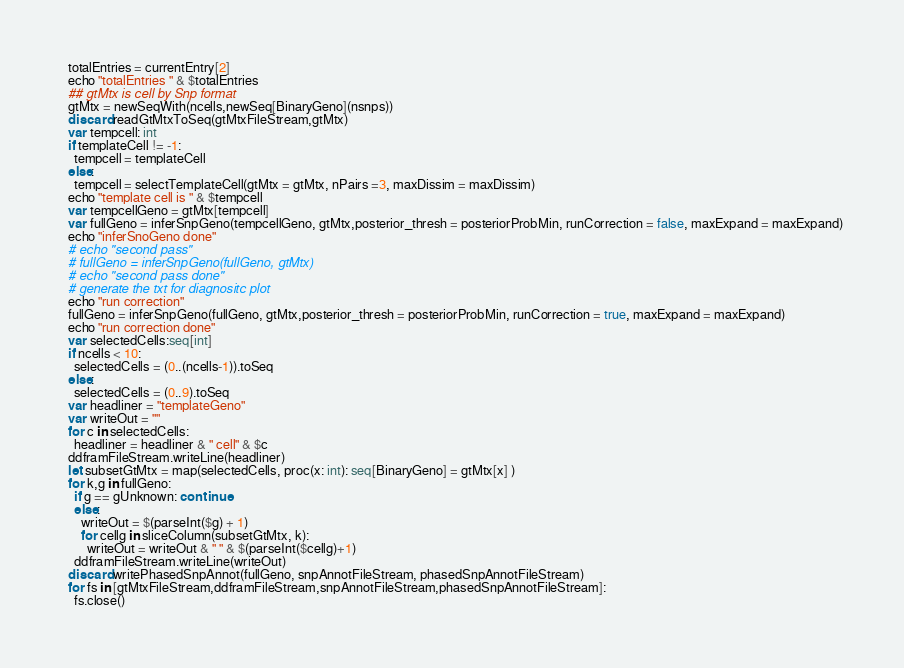Convert code to text. <code><loc_0><loc_0><loc_500><loc_500><_Nim_>  totalEntries = currentEntry[2]
  echo "totalEntries " & $totalEntries
  ## gtMtx is cell by Snp format
  gtMtx = newSeqWith(ncells,newSeq[BinaryGeno](nsnps))
  discard readGtMtxToSeq(gtMtxFileStream,gtMtx)
  var tempcell: int
  if templateCell != -1:
    tempcell = templateCell
  else:
    tempcell = selectTemplateCell(gtMtx = gtMtx, nPairs =3, maxDissim = maxDissim)
  echo "template cell is " & $tempcell
  var tempcellGeno = gtMtx[tempcell]
  var fullGeno = inferSnpGeno(tempcellGeno, gtMtx,posterior_thresh = posteriorProbMin, runCorrection = false, maxExpand = maxExpand)
  echo "inferSnoGeno done"
  # echo "second pass"
  # fullGeno = inferSnpGeno(fullGeno, gtMtx)
  # echo "second pass done"
  # generate the txt for diagnositc plot
  echo "run correction"
  fullGeno = inferSnpGeno(fullGeno, gtMtx,posterior_thresh = posteriorProbMin, runCorrection = true, maxExpand = maxExpand)
  echo "run correction done"
  var selectedCells:seq[int]
  if ncells < 10:
    selectedCells = (0..(ncells-1)).toSeq
  else:
    selectedCells = (0..9).toSeq
  var headliner = "templateGeno"
  var writeOut = ""
  for c in selectedCells:
    headliner = headliner & " cell" & $c
  ddframFileStream.writeLine(headliner)
  let subsetGtMtx = map(selectedCells, proc(x: int): seq[BinaryGeno] = gtMtx[x] )
  for k,g in fullGeno:
    if g == gUnknown: continue
    else:
      writeOut = $(parseInt($g) + 1) 
      for cellg in sliceColumn(subsetGtMtx, k):
        writeOut = writeOut & " " & $(parseInt($cellg)+1)
    ddframFileStream.writeLine(writeOut)
  discard writePhasedSnpAnnot(fullGeno, snpAnnotFileStream, phasedSnpAnnotFileStream)
  for fs in [gtMtxFileStream,ddframFileStream,snpAnnotFileStream,phasedSnpAnnotFileStream]:
    fs.close()
</code> 